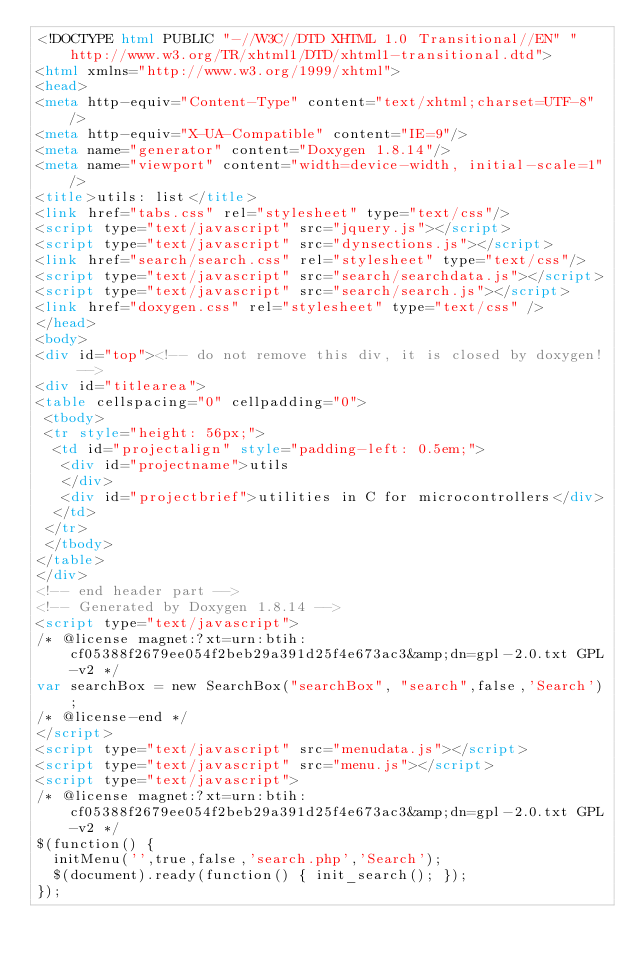Convert code to text. <code><loc_0><loc_0><loc_500><loc_500><_HTML_><!DOCTYPE html PUBLIC "-//W3C//DTD XHTML 1.0 Transitional//EN" "http://www.w3.org/TR/xhtml1/DTD/xhtml1-transitional.dtd">
<html xmlns="http://www.w3.org/1999/xhtml">
<head>
<meta http-equiv="Content-Type" content="text/xhtml;charset=UTF-8"/>
<meta http-equiv="X-UA-Compatible" content="IE=9"/>
<meta name="generator" content="Doxygen 1.8.14"/>
<meta name="viewport" content="width=device-width, initial-scale=1"/>
<title>utils: list</title>
<link href="tabs.css" rel="stylesheet" type="text/css"/>
<script type="text/javascript" src="jquery.js"></script>
<script type="text/javascript" src="dynsections.js"></script>
<link href="search/search.css" rel="stylesheet" type="text/css"/>
<script type="text/javascript" src="search/searchdata.js"></script>
<script type="text/javascript" src="search/search.js"></script>
<link href="doxygen.css" rel="stylesheet" type="text/css" />
</head>
<body>
<div id="top"><!-- do not remove this div, it is closed by doxygen! -->
<div id="titlearea">
<table cellspacing="0" cellpadding="0">
 <tbody>
 <tr style="height: 56px;">
  <td id="projectalign" style="padding-left: 0.5em;">
   <div id="projectname">utils
   </div>
   <div id="projectbrief">utilities in C for microcontrollers</div>
  </td>
 </tr>
 </tbody>
</table>
</div>
<!-- end header part -->
<!-- Generated by Doxygen 1.8.14 -->
<script type="text/javascript">
/* @license magnet:?xt=urn:btih:cf05388f2679ee054f2beb29a391d25f4e673ac3&amp;dn=gpl-2.0.txt GPL-v2 */
var searchBox = new SearchBox("searchBox", "search",false,'Search');
/* @license-end */
</script>
<script type="text/javascript" src="menudata.js"></script>
<script type="text/javascript" src="menu.js"></script>
<script type="text/javascript">
/* @license magnet:?xt=urn:btih:cf05388f2679ee054f2beb29a391d25f4e673ac3&amp;dn=gpl-2.0.txt GPL-v2 */
$(function() {
  initMenu('',true,false,'search.php','Search');
  $(document).ready(function() { init_search(); });
});</code> 